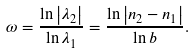Convert formula to latex. <formula><loc_0><loc_0><loc_500><loc_500>\omega = \frac { \ln \left | \lambda _ { 2 } \right | } { \ln \lambda _ { 1 } } = \frac { \ln \left | n _ { 2 } - n _ { 1 } \right | } { \ln b } .</formula> 